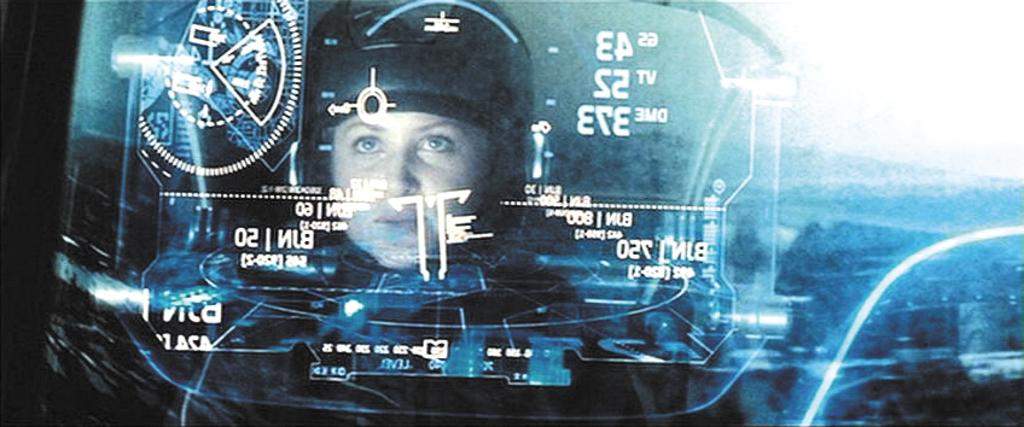What is the main object in the image? There is a screen in the image. What can be seen on the screen? There is text visible on the screen. Are there any people in the image? Yes, there is a woman in the image. How many cattle are present in the image? There are no cattle present in the image. What is the plot of the story being displayed on the screen? The provided facts do not mention a story or plot being displayed on the screen, so it cannot be determined from the image. 